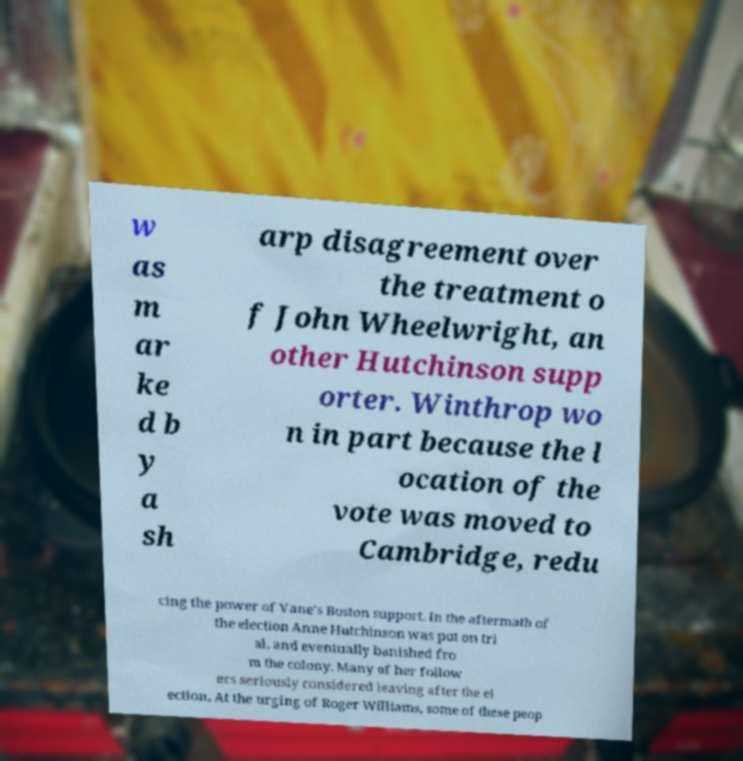Can you read and provide the text displayed in the image?This photo seems to have some interesting text. Can you extract and type it out for me? w as m ar ke d b y a sh arp disagreement over the treatment o f John Wheelwright, an other Hutchinson supp orter. Winthrop wo n in part because the l ocation of the vote was moved to Cambridge, redu cing the power of Vane's Boston support. In the aftermath of the election Anne Hutchinson was put on tri al, and eventually banished fro m the colony. Many of her follow ers seriously considered leaving after the el ection. At the urging of Roger Williams, some of these peop 